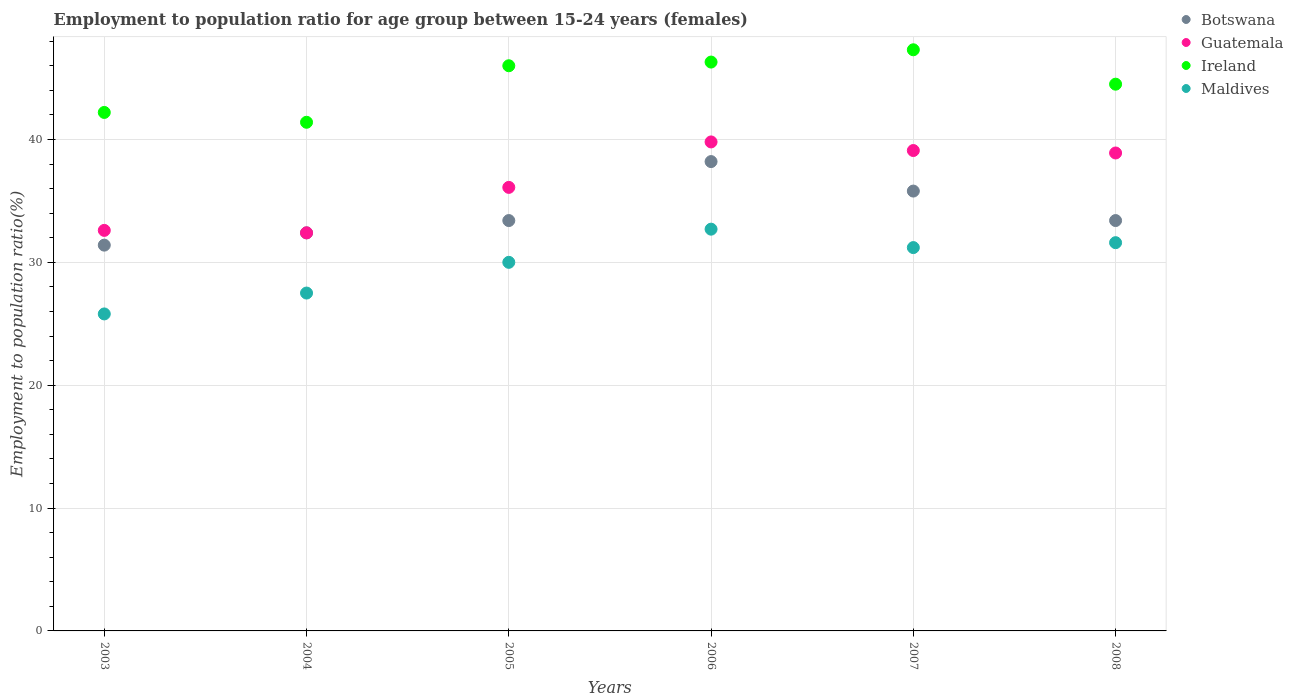How many different coloured dotlines are there?
Provide a succinct answer. 4. What is the employment to population ratio in Guatemala in 2004?
Provide a short and direct response. 32.4. Across all years, what is the maximum employment to population ratio in Maldives?
Offer a very short reply. 32.7. Across all years, what is the minimum employment to population ratio in Botswana?
Your response must be concise. 31.4. In which year was the employment to population ratio in Botswana minimum?
Your answer should be very brief. 2003. What is the total employment to population ratio in Ireland in the graph?
Give a very brief answer. 267.7. What is the difference between the employment to population ratio in Maldives in 2005 and that in 2008?
Provide a short and direct response. -1.6. What is the difference between the employment to population ratio in Maldives in 2004 and the employment to population ratio in Guatemala in 2007?
Provide a short and direct response. -11.6. What is the average employment to population ratio in Maldives per year?
Provide a succinct answer. 29.8. What is the ratio of the employment to population ratio in Guatemala in 2007 to that in 2008?
Offer a terse response. 1.01. Is the employment to population ratio in Guatemala in 2004 less than that in 2005?
Offer a terse response. Yes. Is the difference between the employment to population ratio in Guatemala in 2003 and 2006 greater than the difference between the employment to population ratio in Botswana in 2003 and 2006?
Your answer should be compact. No. What is the difference between the highest and the second highest employment to population ratio in Botswana?
Ensure brevity in your answer.  2.4. What is the difference between the highest and the lowest employment to population ratio in Ireland?
Offer a very short reply. 5.9. Is it the case that in every year, the sum of the employment to population ratio in Maldives and employment to population ratio in Ireland  is greater than the sum of employment to population ratio in Botswana and employment to population ratio in Guatemala?
Your answer should be compact. No. Is the employment to population ratio in Ireland strictly less than the employment to population ratio in Maldives over the years?
Give a very brief answer. No. How many dotlines are there?
Your answer should be very brief. 4. How many years are there in the graph?
Provide a short and direct response. 6. Does the graph contain grids?
Offer a terse response. Yes. How are the legend labels stacked?
Your answer should be compact. Vertical. What is the title of the graph?
Provide a succinct answer. Employment to population ratio for age group between 15-24 years (females). Does "Greenland" appear as one of the legend labels in the graph?
Keep it short and to the point. No. What is the label or title of the Y-axis?
Your response must be concise. Employment to population ratio(%). What is the Employment to population ratio(%) of Botswana in 2003?
Your response must be concise. 31.4. What is the Employment to population ratio(%) of Guatemala in 2003?
Your response must be concise. 32.6. What is the Employment to population ratio(%) in Ireland in 2003?
Make the answer very short. 42.2. What is the Employment to population ratio(%) of Maldives in 2003?
Ensure brevity in your answer.  25.8. What is the Employment to population ratio(%) of Botswana in 2004?
Offer a terse response. 32.4. What is the Employment to population ratio(%) in Guatemala in 2004?
Your response must be concise. 32.4. What is the Employment to population ratio(%) in Ireland in 2004?
Offer a very short reply. 41.4. What is the Employment to population ratio(%) in Botswana in 2005?
Give a very brief answer. 33.4. What is the Employment to population ratio(%) in Guatemala in 2005?
Provide a succinct answer. 36.1. What is the Employment to population ratio(%) of Ireland in 2005?
Provide a short and direct response. 46. What is the Employment to population ratio(%) in Maldives in 2005?
Keep it short and to the point. 30. What is the Employment to population ratio(%) in Botswana in 2006?
Provide a short and direct response. 38.2. What is the Employment to population ratio(%) in Guatemala in 2006?
Ensure brevity in your answer.  39.8. What is the Employment to population ratio(%) of Ireland in 2006?
Offer a terse response. 46.3. What is the Employment to population ratio(%) of Maldives in 2006?
Your answer should be very brief. 32.7. What is the Employment to population ratio(%) in Botswana in 2007?
Your answer should be very brief. 35.8. What is the Employment to population ratio(%) of Guatemala in 2007?
Keep it short and to the point. 39.1. What is the Employment to population ratio(%) in Ireland in 2007?
Your answer should be compact. 47.3. What is the Employment to population ratio(%) in Maldives in 2007?
Offer a very short reply. 31.2. What is the Employment to population ratio(%) of Botswana in 2008?
Give a very brief answer. 33.4. What is the Employment to population ratio(%) in Guatemala in 2008?
Make the answer very short. 38.9. What is the Employment to population ratio(%) of Ireland in 2008?
Give a very brief answer. 44.5. What is the Employment to population ratio(%) in Maldives in 2008?
Give a very brief answer. 31.6. Across all years, what is the maximum Employment to population ratio(%) in Botswana?
Provide a succinct answer. 38.2. Across all years, what is the maximum Employment to population ratio(%) of Guatemala?
Give a very brief answer. 39.8. Across all years, what is the maximum Employment to population ratio(%) in Ireland?
Your response must be concise. 47.3. Across all years, what is the maximum Employment to population ratio(%) of Maldives?
Give a very brief answer. 32.7. Across all years, what is the minimum Employment to population ratio(%) of Botswana?
Offer a very short reply. 31.4. Across all years, what is the minimum Employment to population ratio(%) in Guatemala?
Your answer should be compact. 32.4. Across all years, what is the minimum Employment to population ratio(%) of Ireland?
Offer a terse response. 41.4. Across all years, what is the minimum Employment to population ratio(%) of Maldives?
Give a very brief answer. 25.8. What is the total Employment to population ratio(%) of Botswana in the graph?
Your answer should be very brief. 204.6. What is the total Employment to population ratio(%) in Guatemala in the graph?
Offer a terse response. 218.9. What is the total Employment to population ratio(%) of Ireland in the graph?
Ensure brevity in your answer.  267.7. What is the total Employment to population ratio(%) in Maldives in the graph?
Your response must be concise. 178.8. What is the difference between the Employment to population ratio(%) in Botswana in 2003 and that in 2004?
Your answer should be very brief. -1. What is the difference between the Employment to population ratio(%) of Guatemala in 2003 and that in 2004?
Offer a terse response. 0.2. What is the difference between the Employment to population ratio(%) in Botswana in 2003 and that in 2006?
Offer a terse response. -6.8. What is the difference between the Employment to population ratio(%) of Botswana in 2003 and that in 2007?
Offer a terse response. -4.4. What is the difference between the Employment to population ratio(%) of Guatemala in 2003 and that in 2007?
Provide a short and direct response. -6.5. What is the difference between the Employment to population ratio(%) of Botswana in 2003 and that in 2008?
Give a very brief answer. -2. What is the difference between the Employment to population ratio(%) of Ireland in 2003 and that in 2008?
Offer a very short reply. -2.3. What is the difference between the Employment to population ratio(%) of Botswana in 2004 and that in 2005?
Keep it short and to the point. -1. What is the difference between the Employment to population ratio(%) of Guatemala in 2004 and that in 2005?
Your response must be concise. -3.7. What is the difference between the Employment to population ratio(%) in Maldives in 2004 and that in 2005?
Provide a short and direct response. -2.5. What is the difference between the Employment to population ratio(%) in Maldives in 2004 and that in 2006?
Offer a terse response. -5.2. What is the difference between the Employment to population ratio(%) in Botswana in 2004 and that in 2007?
Make the answer very short. -3.4. What is the difference between the Employment to population ratio(%) in Guatemala in 2004 and that in 2007?
Provide a succinct answer. -6.7. What is the difference between the Employment to population ratio(%) in Maldives in 2004 and that in 2007?
Provide a succinct answer. -3.7. What is the difference between the Employment to population ratio(%) of Botswana in 2004 and that in 2008?
Make the answer very short. -1. What is the difference between the Employment to population ratio(%) in Ireland in 2004 and that in 2008?
Provide a succinct answer. -3.1. What is the difference between the Employment to population ratio(%) in Maldives in 2004 and that in 2008?
Make the answer very short. -4.1. What is the difference between the Employment to population ratio(%) in Guatemala in 2005 and that in 2006?
Provide a short and direct response. -3.7. What is the difference between the Employment to population ratio(%) in Botswana in 2005 and that in 2007?
Provide a succinct answer. -2.4. What is the difference between the Employment to population ratio(%) of Guatemala in 2005 and that in 2008?
Provide a short and direct response. -2.8. What is the difference between the Employment to population ratio(%) in Botswana in 2006 and that in 2007?
Ensure brevity in your answer.  2.4. What is the difference between the Employment to population ratio(%) in Guatemala in 2006 and that in 2007?
Provide a short and direct response. 0.7. What is the difference between the Employment to population ratio(%) in Guatemala in 2006 and that in 2008?
Your response must be concise. 0.9. What is the difference between the Employment to population ratio(%) in Ireland in 2006 and that in 2008?
Provide a short and direct response. 1.8. What is the difference between the Employment to population ratio(%) of Maldives in 2006 and that in 2008?
Give a very brief answer. 1.1. What is the difference between the Employment to population ratio(%) of Botswana in 2007 and that in 2008?
Make the answer very short. 2.4. What is the difference between the Employment to population ratio(%) of Guatemala in 2007 and that in 2008?
Your answer should be very brief. 0.2. What is the difference between the Employment to population ratio(%) of Ireland in 2007 and that in 2008?
Keep it short and to the point. 2.8. What is the difference between the Employment to population ratio(%) of Maldives in 2007 and that in 2008?
Provide a short and direct response. -0.4. What is the difference between the Employment to population ratio(%) of Botswana in 2003 and the Employment to population ratio(%) of Guatemala in 2004?
Give a very brief answer. -1. What is the difference between the Employment to population ratio(%) in Botswana in 2003 and the Employment to population ratio(%) in Maldives in 2004?
Your answer should be compact. 3.9. What is the difference between the Employment to population ratio(%) of Ireland in 2003 and the Employment to population ratio(%) of Maldives in 2004?
Your response must be concise. 14.7. What is the difference between the Employment to population ratio(%) in Botswana in 2003 and the Employment to population ratio(%) in Guatemala in 2005?
Keep it short and to the point. -4.7. What is the difference between the Employment to population ratio(%) in Botswana in 2003 and the Employment to population ratio(%) in Ireland in 2005?
Give a very brief answer. -14.6. What is the difference between the Employment to population ratio(%) in Botswana in 2003 and the Employment to population ratio(%) in Maldives in 2005?
Offer a very short reply. 1.4. What is the difference between the Employment to population ratio(%) of Botswana in 2003 and the Employment to population ratio(%) of Ireland in 2006?
Your response must be concise. -14.9. What is the difference between the Employment to population ratio(%) of Guatemala in 2003 and the Employment to population ratio(%) of Ireland in 2006?
Make the answer very short. -13.7. What is the difference between the Employment to population ratio(%) of Guatemala in 2003 and the Employment to population ratio(%) of Maldives in 2006?
Your response must be concise. -0.1. What is the difference between the Employment to population ratio(%) in Ireland in 2003 and the Employment to population ratio(%) in Maldives in 2006?
Provide a succinct answer. 9.5. What is the difference between the Employment to population ratio(%) of Botswana in 2003 and the Employment to population ratio(%) of Ireland in 2007?
Provide a short and direct response. -15.9. What is the difference between the Employment to population ratio(%) in Guatemala in 2003 and the Employment to population ratio(%) in Ireland in 2007?
Your response must be concise. -14.7. What is the difference between the Employment to population ratio(%) of Guatemala in 2003 and the Employment to population ratio(%) of Maldives in 2007?
Your answer should be very brief. 1.4. What is the difference between the Employment to population ratio(%) of Botswana in 2003 and the Employment to population ratio(%) of Guatemala in 2008?
Your answer should be compact. -7.5. What is the difference between the Employment to population ratio(%) of Guatemala in 2003 and the Employment to population ratio(%) of Ireland in 2008?
Your response must be concise. -11.9. What is the difference between the Employment to population ratio(%) in Ireland in 2003 and the Employment to population ratio(%) in Maldives in 2008?
Your response must be concise. 10.6. What is the difference between the Employment to population ratio(%) of Botswana in 2004 and the Employment to population ratio(%) of Ireland in 2005?
Keep it short and to the point. -13.6. What is the difference between the Employment to population ratio(%) in Botswana in 2004 and the Employment to population ratio(%) in Guatemala in 2006?
Your answer should be compact. -7.4. What is the difference between the Employment to population ratio(%) of Guatemala in 2004 and the Employment to population ratio(%) of Maldives in 2006?
Keep it short and to the point. -0.3. What is the difference between the Employment to population ratio(%) of Botswana in 2004 and the Employment to population ratio(%) of Guatemala in 2007?
Give a very brief answer. -6.7. What is the difference between the Employment to population ratio(%) in Botswana in 2004 and the Employment to population ratio(%) in Ireland in 2007?
Offer a very short reply. -14.9. What is the difference between the Employment to population ratio(%) in Botswana in 2004 and the Employment to population ratio(%) in Maldives in 2007?
Your answer should be very brief. 1.2. What is the difference between the Employment to population ratio(%) of Guatemala in 2004 and the Employment to population ratio(%) of Ireland in 2007?
Offer a terse response. -14.9. What is the difference between the Employment to population ratio(%) of Ireland in 2004 and the Employment to population ratio(%) of Maldives in 2007?
Your answer should be very brief. 10.2. What is the difference between the Employment to population ratio(%) of Botswana in 2004 and the Employment to population ratio(%) of Guatemala in 2008?
Offer a terse response. -6.5. What is the difference between the Employment to population ratio(%) of Guatemala in 2004 and the Employment to population ratio(%) of Ireland in 2008?
Ensure brevity in your answer.  -12.1. What is the difference between the Employment to population ratio(%) in Guatemala in 2004 and the Employment to population ratio(%) in Maldives in 2008?
Give a very brief answer. 0.8. What is the difference between the Employment to population ratio(%) of Ireland in 2004 and the Employment to population ratio(%) of Maldives in 2008?
Make the answer very short. 9.8. What is the difference between the Employment to population ratio(%) of Guatemala in 2005 and the Employment to population ratio(%) of Maldives in 2006?
Keep it short and to the point. 3.4. What is the difference between the Employment to population ratio(%) in Botswana in 2005 and the Employment to population ratio(%) in Ireland in 2007?
Keep it short and to the point. -13.9. What is the difference between the Employment to population ratio(%) of Guatemala in 2005 and the Employment to population ratio(%) of Maldives in 2007?
Your answer should be compact. 4.9. What is the difference between the Employment to population ratio(%) in Ireland in 2005 and the Employment to population ratio(%) in Maldives in 2007?
Your response must be concise. 14.8. What is the difference between the Employment to population ratio(%) of Botswana in 2005 and the Employment to population ratio(%) of Guatemala in 2008?
Give a very brief answer. -5.5. What is the difference between the Employment to population ratio(%) in Botswana in 2005 and the Employment to population ratio(%) in Ireland in 2008?
Ensure brevity in your answer.  -11.1. What is the difference between the Employment to population ratio(%) in Botswana in 2005 and the Employment to population ratio(%) in Maldives in 2008?
Your answer should be compact. 1.8. What is the difference between the Employment to population ratio(%) of Guatemala in 2005 and the Employment to population ratio(%) of Ireland in 2008?
Make the answer very short. -8.4. What is the difference between the Employment to population ratio(%) in Ireland in 2005 and the Employment to population ratio(%) in Maldives in 2008?
Your response must be concise. 14.4. What is the difference between the Employment to population ratio(%) of Botswana in 2006 and the Employment to population ratio(%) of Guatemala in 2007?
Keep it short and to the point. -0.9. What is the difference between the Employment to population ratio(%) in Botswana in 2006 and the Employment to population ratio(%) in Ireland in 2007?
Your response must be concise. -9.1. What is the difference between the Employment to population ratio(%) of Botswana in 2006 and the Employment to population ratio(%) of Maldives in 2007?
Give a very brief answer. 7. What is the difference between the Employment to population ratio(%) in Ireland in 2006 and the Employment to population ratio(%) in Maldives in 2007?
Provide a succinct answer. 15.1. What is the difference between the Employment to population ratio(%) in Botswana in 2006 and the Employment to population ratio(%) in Guatemala in 2008?
Provide a short and direct response. -0.7. What is the difference between the Employment to population ratio(%) of Botswana in 2006 and the Employment to population ratio(%) of Ireland in 2008?
Offer a very short reply. -6.3. What is the difference between the Employment to population ratio(%) of Botswana in 2006 and the Employment to population ratio(%) of Maldives in 2008?
Make the answer very short. 6.6. What is the difference between the Employment to population ratio(%) of Botswana in 2007 and the Employment to population ratio(%) of Guatemala in 2008?
Your answer should be very brief. -3.1. What is the difference between the Employment to population ratio(%) in Botswana in 2007 and the Employment to population ratio(%) in Maldives in 2008?
Offer a very short reply. 4.2. What is the difference between the Employment to population ratio(%) of Guatemala in 2007 and the Employment to population ratio(%) of Ireland in 2008?
Provide a short and direct response. -5.4. What is the difference between the Employment to population ratio(%) in Ireland in 2007 and the Employment to population ratio(%) in Maldives in 2008?
Make the answer very short. 15.7. What is the average Employment to population ratio(%) of Botswana per year?
Keep it short and to the point. 34.1. What is the average Employment to population ratio(%) in Guatemala per year?
Make the answer very short. 36.48. What is the average Employment to population ratio(%) in Ireland per year?
Ensure brevity in your answer.  44.62. What is the average Employment to population ratio(%) of Maldives per year?
Offer a very short reply. 29.8. In the year 2003, what is the difference between the Employment to population ratio(%) in Botswana and Employment to population ratio(%) in Maldives?
Make the answer very short. 5.6. In the year 2003, what is the difference between the Employment to population ratio(%) in Guatemala and Employment to population ratio(%) in Ireland?
Ensure brevity in your answer.  -9.6. In the year 2003, what is the difference between the Employment to population ratio(%) in Guatemala and Employment to population ratio(%) in Maldives?
Give a very brief answer. 6.8. In the year 2003, what is the difference between the Employment to population ratio(%) in Ireland and Employment to population ratio(%) in Maldives?
Keep it short and to the point. 16.4. In the year 2004, what is the difference between the Employment to population ratio(%) of Botswana and Employment to population ratio(%) of Ireland?
Provide a short and direct response. -9. In the year 2004, what is the difference between the Employment to population ratio(%) in Botswana and Employment to population ratio(%) in Maldives?
Your response must be concise. 4.9. In the year 2004, what is the difference between the Employment to population ratio(%) in Ireland and Employment to population ratio(%) in Maldives?
Offer a very short reply. 13.9. In the year 2005, what is the difference between the Employment to population ratio(%) of Ireland and Employment to population ratio(%) of Maldives?
Your response must be concise. 16. In the year 2006, what is the difference between the Employment to population ratio(%) of Botswana and Employment to population ratio(%) of Guatemala?
Offer a terse response. -1.6. In the year 2006, what is the difference between the Employment to population ratio(%) in Botswana and Employment to population ratio(%) in Maldives?
Offer a terse response. 5.5. In the year 2006, what is the difference between the Employment to population ratio(%) in Guatemala and Employment to population ratio(%) in Maldives?
Your answer should be very brief. 7.1. In the year 2007, what is the difference between the Employment to population ratio(%) of Guatemala and Employment to population ratio(%) of Ireland?
Keep it short and to the point. -8.2. In the year 2007, what is the difference between the Employment to population ratio(%) in Ireland and Employment to population ratio(%) in Maldives?
Offer a very short reply. 16.1. In the year 2008, what is the difference between the Employment to population ratio(%) in Botswana and Employment to population ratio(%) in Ireland?
Ensure brevity in your answer.  -11.1. In the year 2008, what is the difference between the Employment to population ratio(%) of Guatemala and Employment to population ratio(%) of Maldives?
Make the answer very short. 7.3. What is the ratio of the Employment to population ratio(%) in Botswana in 2003 to that in 2004?
Make the answer very short. 0.97. What is the ratio of the Employment to population ratio(%) in Guatemala in 2003 to that in 2004?
Offer a very short reply. 1.01. What is the ratio of the Employment to population ratio(%) of Ireland in 2003 to that in 2004?
Provide a succinct answer. 1.02. What is the ratio of the Employment to population ratio(%) of Maldives in 2003 to that in 2004?
Your response must be concise. 0.94. What is the ratio of the Employment to population ratio(%) of Botswana in 2003 to that in 2005?
Ensure brevity in your answer.  0.94. What is the ratio of the Employment to population ratio(%) of Guatemala in 2003 to that in 2005?
Provide a short and direct response. 0.9. What is the ratio of the Employment to population ratio(%) of Ireland in 2003 to that in 2005?
Offer a very short reply. 0.92. What is the ratio of the Employment to population ratio(%) of Maldives in 2003 to that in 2005?
Your answer should be compact. 0.86. What is the ratio of the Employment to population ratio(%) of Botswana in 2003 to that in 2006?
Give a very brief answer. 0.82. What is the ratio of the Employment to population ratio(%) of Guatemala in 2003 to that in 2006?
Your answer should be very brief. 0.82. What is the ratio of the Employment to population ratio(%) of Ireland in 2003 to that in 2006?
Keep it short and to the point. 0.91. What is the ratio of the Employment to population ratio(%) of Maldives in 2003 to that in 2006?
Offer a very short reply. 0.79. What is the ratio of the Employment to population ratio(%) of Botswana in 2003 to that in 2007?
Ensure brevity in your answer.  0.88. What is the ratio of the Employment to population ratio(%) of Guatemala in 2003 to that in 2007?
Your response must be concise. 0.83. What is the ratio of the Employment to population ratio(%) in Ireland in 2003 to that in 2007?
Your answer should be very brief. 0.89. What is the ratio of the Employment to population ratio(%) in Maldives in 2003 to that in 2007?
Give a very brief answer. 0.83. What is the ratio of the Employment to population ratio(%) in Botswana in 2003 to that in 2008?
Provide a short and direct response. 0.94. What is the ratio of the Employment to population ratio(%) in Guatemala in 2003 to that in 2008?
Your answer should be compact. 0.84. What is the ratio of the Employment to population ratio(%) in Ireland in 2003 to that in 2008?
Provide a succinct answer. 0.95. What is the ratio of the Employment to population ratio(%) in Maldives in 2003 to that in 2008?
Make the answer very short. 0.82. What is the ratio of the Employment to population ratio(%) in Botswana in 2004 to that in 2005?
Your answer should be compact. 0.97. What is the ratio of the Employment to population ratio(%) in Guatemala in 2004 to that in 2005?
Your answer should be compact. 0.9. What is the ratio of the Employment to population ratio(%) of Ireland in 2004 to that in 2005?
Ensure brevity in your answer.  0.9. What is the ratio of the Employment to population ratio(%) in Botswana in 2004 to that in 2006?
Keep it short and to the point. 0.85. What is the ratio of the Employment to population ratio(%) of Guatemala in 2004 to that in 2006?
Your response must be concise. 0.81. What is the ratio of the Employment to population ratio(%) of Ireland in 2004 to that in 2006?
Make the answer very short. 0.89. What is the ratio of the Employment to population ratio(%) of Maldives in 2004 to that in 2006?
Ensure brevity in your answer.  0.84. What is the ratio of the Employment to population ratio(%) in Botswana in 2004 to that in 2007?
Your answer should be compact. 0.91. What is the ratio of the Employment to population ratio(%) in Guatemala in 2004 to that in 2007?
Your answer should be compact. 0.83. What is the ratio of the Employment to population ratio(%) of Ireland in 2004 to that in 2007?
Ensure brevity in your answer.  0.88. What is the ratio of the Employment to population ratio(%) of Maldives in 2004 to that in 2007?
Ensure brevity in your answer.  0.88. What is the ratio of the Employment to population ratio(%) in Botswana in 2004 to that in 2008?
Provide a succinct answer. 0.97. What is the ratio of the Employment to population ratio(%) of Guatemala in 2004 to that in 2008?
Provide a short and direct response. 0.83. What is the ratio of the Employment to population ratio(%) of Ireland in 2004 to that in 2008?
Make the answer very short. 0.93. What is the ratio of the Employment to population ratio(%) in Maldives in 2004 to that in 2008?
Offer a terse response. 0.87. What is the ratio of the Employment to population ratio(%) of Botswana in 2005 to that in 2006?
Offer a very short reply. 0.87. What is the ratio of the Employment to population ratio(%) of Guatemala in 2005 to that in 2006?
Provide a succinct answer. 0.91. What is the ratio of the Employment to population ratio(%) of Maldives in 2005 to that in 2006?
Your answer should be very brief. 0.92. What is the ratio of the Employment to population ratio(%) in Botswana in 2005 to that in 2007?
Your answer should be compact. 0.93. What is the ratio of the Employment to population ratio(%) in Guatemala in 2005 to that in 2007?
Make the answer very short. 0.92. What is the ratio of the Employment to population ratio(%) in Ireland in 2005 to that in 2007?
Your answer should be very brief. 0.97. What is the ratio of the Employment to population ratio(%) of Maldives in 2005 to that in 2007?
Provide a succinct answer. 0.96. What is the ratio of the Employment to population ratio(%) in Botswana in 2005 to that in 2008?
Your answer should be very brief. 1. What is the ratio of the Employment to population ratio(%) in Guatemala in 2005 to that in 2008?
Keep it short and to the point. 0.93. What is the ratio of the Employment to population ratio(%) in Ireland in 2005 to that in 2008?
Offer a very short reply. 1.03. What is the ratio of the Employment to population ratio(%) in Maldives in 2005 to that in 2008?
Offer a very short reply. 0.95. What is the ratio of the Employment to population ratio(%) in Botswana in 2006 to that in 2007?
Your answer should be very brief. 1.07. What is the ratio of the Employment to population ratio(%) in Guatemala in 2006 to that in 2007?
Ensure brevity in your answer.  1.02. What is the ratio of the Employment to population ratio(%) in Ireland in 2006 to that in 2007?
Provide a succinct answer. 0.98. What is the ratio of the Employment to population ratio(%) in Maldives in 2006 to that in 2007?
Your answer should be compact. 1.05. What is the ratio of the Employment to population ratio(%) in Botswana in 2006 to that in 2008?
Your response must be concise. 1.14. What is the ratio of the Employment to population ratio(%) of Guatemala in 2006 to that in 2008?
Make the answer very short. 1.02. What is the ratio of the Employment to population ratio(%) of Ireland in 2006 to that in 2008?
Offer a very short reply. 1.04. What is the ratio of the Employment to population ratio(%) in Maldives in 2006 to that in 2008?
Your response must be concise. 1.03. What is the ratio of the Employment to population ratio(%) in Botswana in 2007 to that in 2008?
Provide a short and direct response. 1.07. What is the ratio of the Employment to population ratio(%) in Guatemala in 2007 to that in 2008?
Make the answer very short. 1.01. What is the ratio of the Employment to population ratio(%) in Ireland in 2007 to that in 2008?
Your response must be concise. 1.06. What is the ratio of the Employment to population ratio(%) of Maldives in 2007 to that in 2008?
Provide a short and direct response. 0.99. What is the difference between the highest and the second highest Employment to population ratio(%) in Botswana?
Provide a succinct answer. 2.4. What is the difference between the highest and the second highest Employment to population ratio(%) in Maldives?
Your answer should be compact. 1.1. What is the difference between the highest and the lowest Employment to population ratio(%) in Botswana?
Make the answer very short. 6.8. What is the difference between the highest and the lowest Employment to population ratio(%) of Ireland?
Offer a terse response. 5.9. 